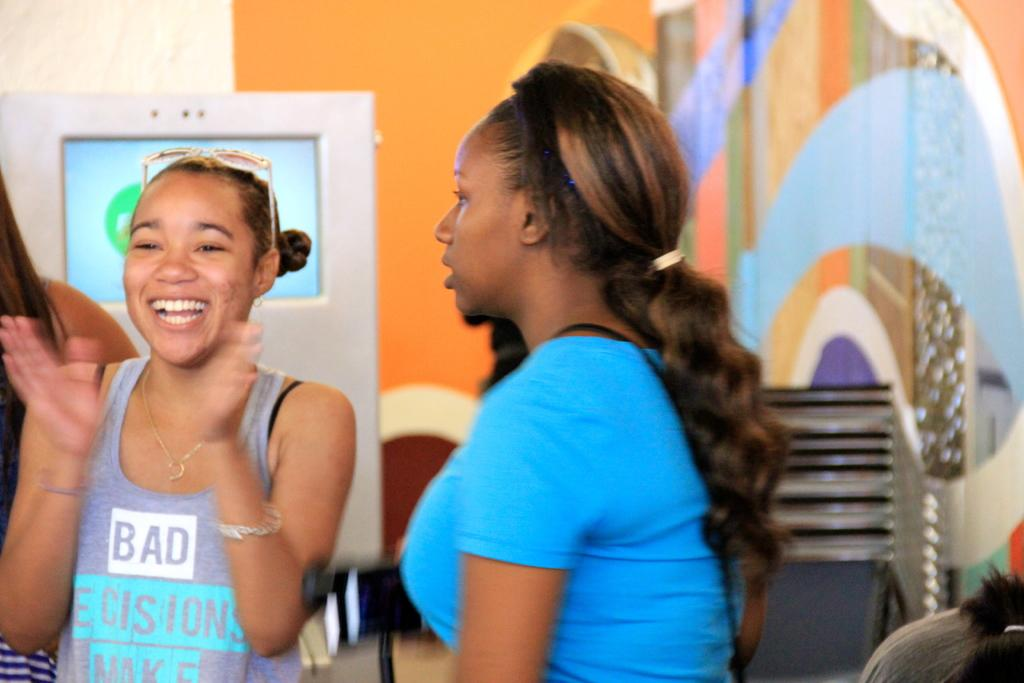How many women are in the image? There are three women in the image. What can be seen in the background of the image? There is a machine, chairs, and a wall in the background of the image. Where is the person located in the image? The person is in the right bottom of the image. What type of flock is being taught by the women in the image? There is no flock or teaching activity depicted in the image. 